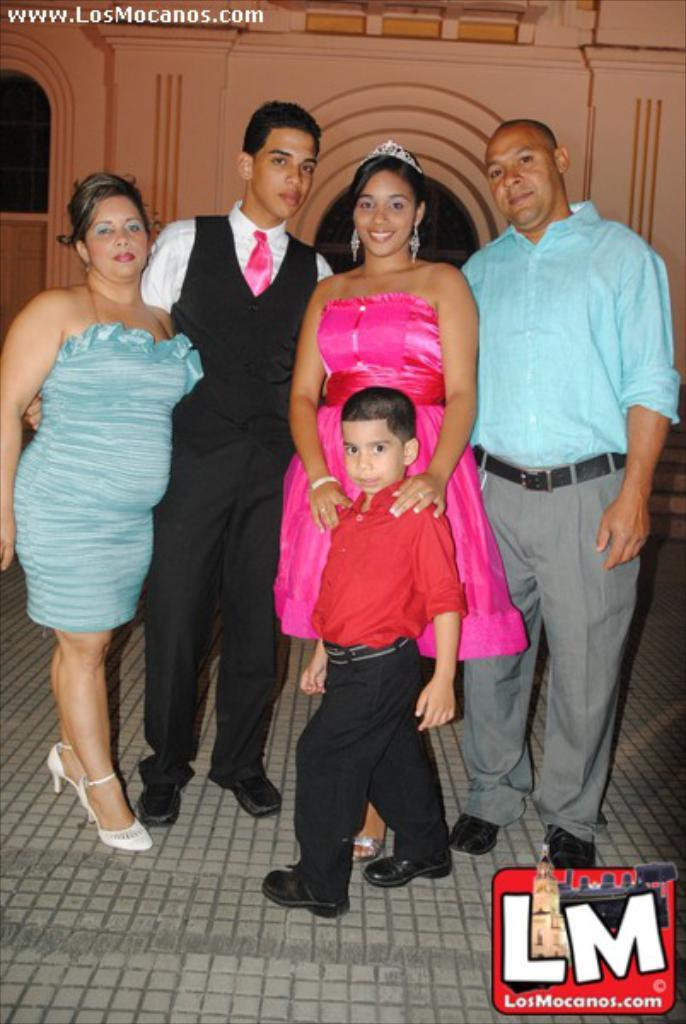How many men are in the image? There are two men in the image. How many women are in the image? There are two women in the image. How many children are in the image? There is one boy in the image. Where are the individuals standing in the image? They are standing on the pavement. What are the individuals doing in the image? They are posing for a camera. What can be seen in the background of the image? There is a wall of a building in the background of the image. What type of lock is the farmer holding in the image? There is no farmer or lock present in the image. What type of loaf is the boy holding in the image? There is no loaf present in the image. 